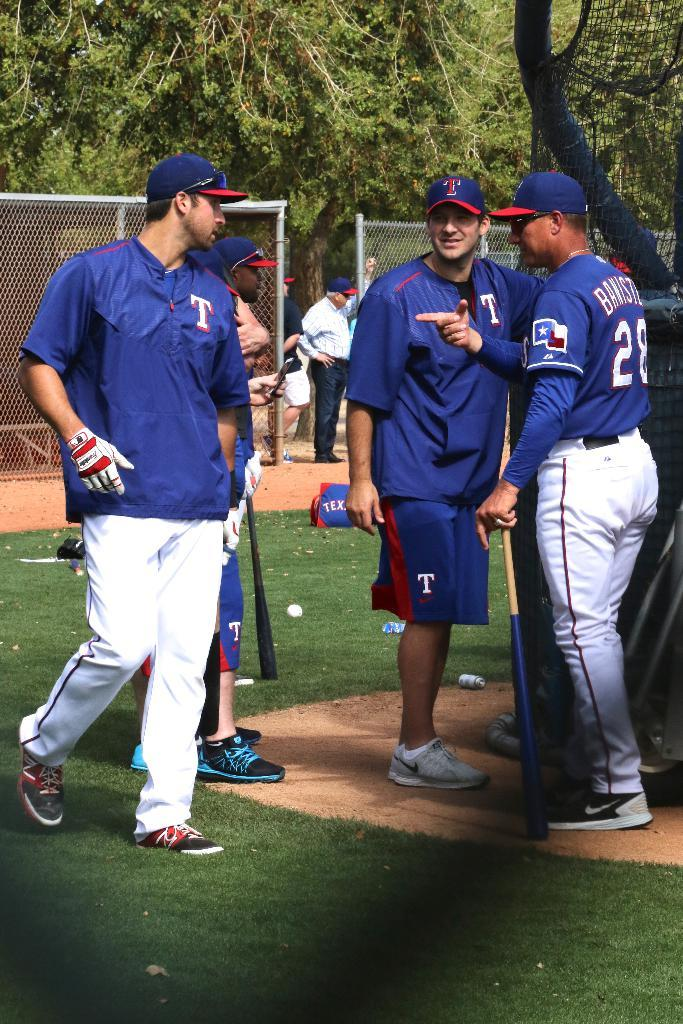<image>
Relay a brief, clear account of the picture shown. A man is wearing a blue jersey with a "28" on the back. 